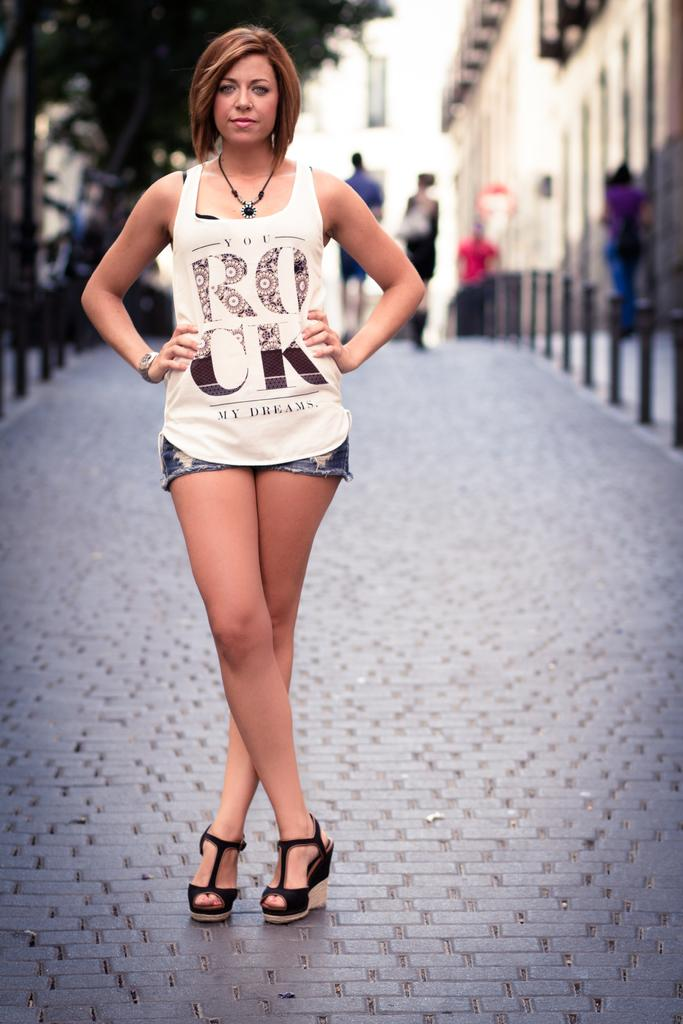What is happening on the road in the image? There are people on the road in the image. What can be seen on both sides of the road? There are poles on both sides of the road. What type of vegetation is visible to the left of the road? There are trees visible to the left of the road. What type of structure is visible to the right of the road? There is a building visible to the right of the road. What type of advice can be seen being given by the turkey to the people on the road? There is no turkey present in the image, and therefore no advice can be seen being given. 